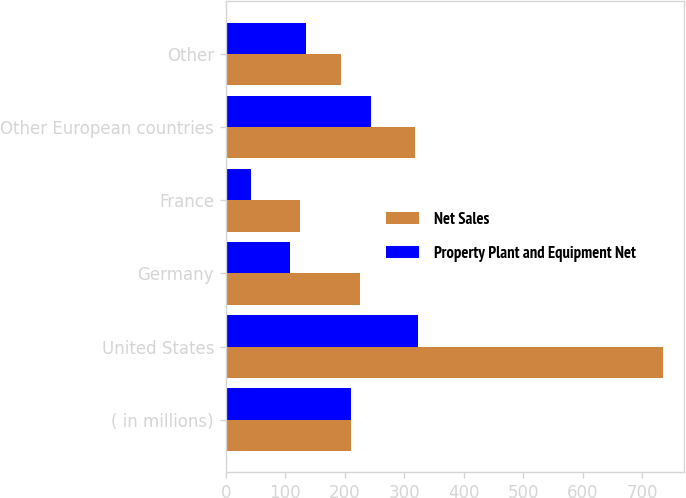<chart> <loc_0><loc_0><loc_500><loc_500><stacked_bar_chart><ecel><fcel>( in millions)<fcel>United States<fcel>Germany<fcel>France<fcel>Other European countries<fcel>Other<nl><fcel>Net Sales<fcel>210.2<fcel>734.6<fcel>226.4<fcel>125.6<fcel>318.5<fcel>194<nl><fcel>Property Plant and Equipment Net<fcel>210.2<fcel>323.8<fcel>108.8<fcel>43.1<fcel>244.9<fcel>134.4<nl></chart> 